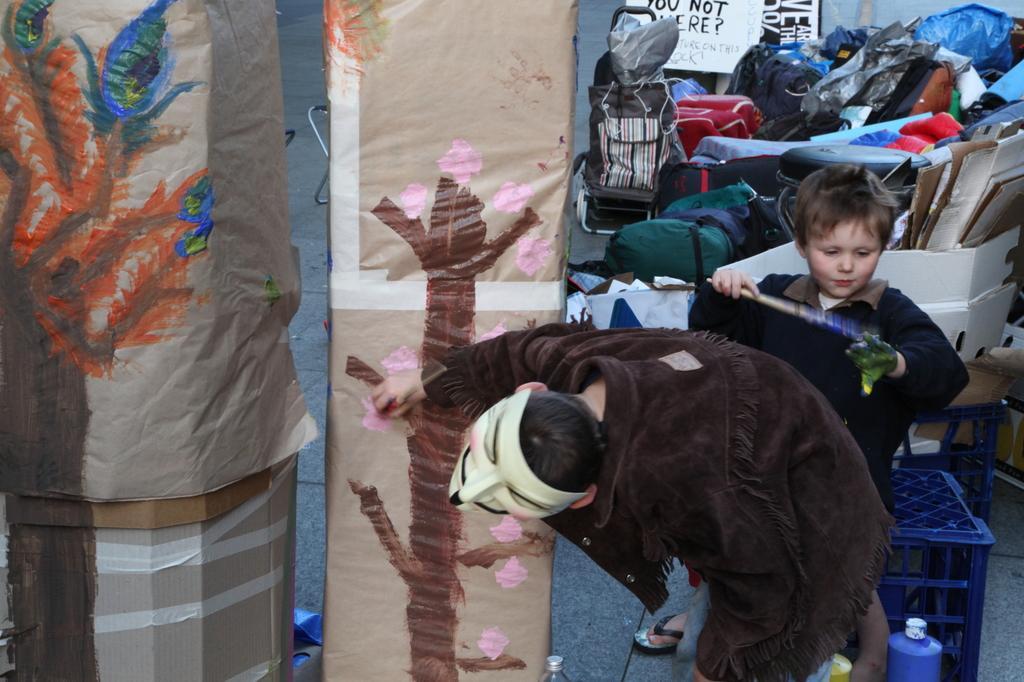How would you summarize this image in a sentence or two? In this picture we can see two kids on the right side, a kid in the front is wearing a mask, a kid on the right side is holding a stick, in the background there are some bags, on the left side we can see covers, there is a tray at the right bottom, we can also see a board in the background. 